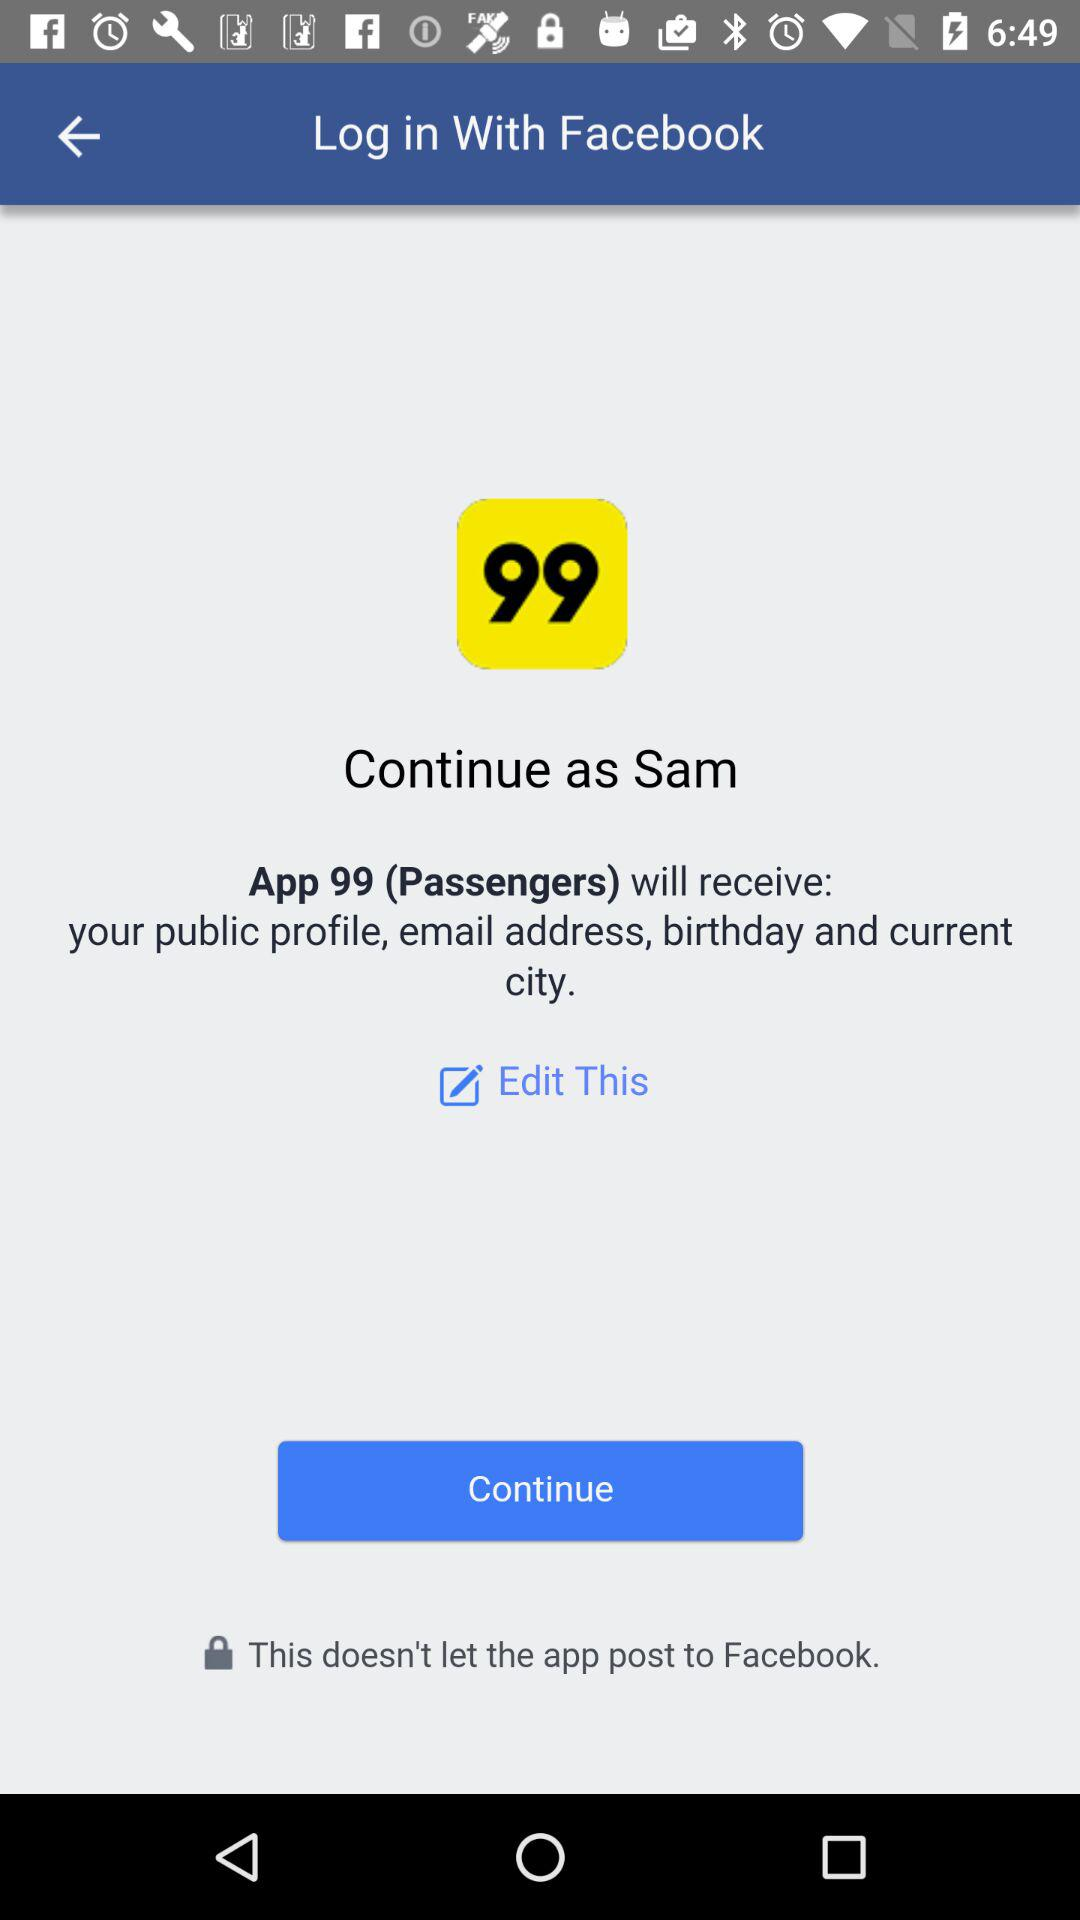When was this last edited?
When the provided information is insufficient, respond with <no answer>. <no answer> 